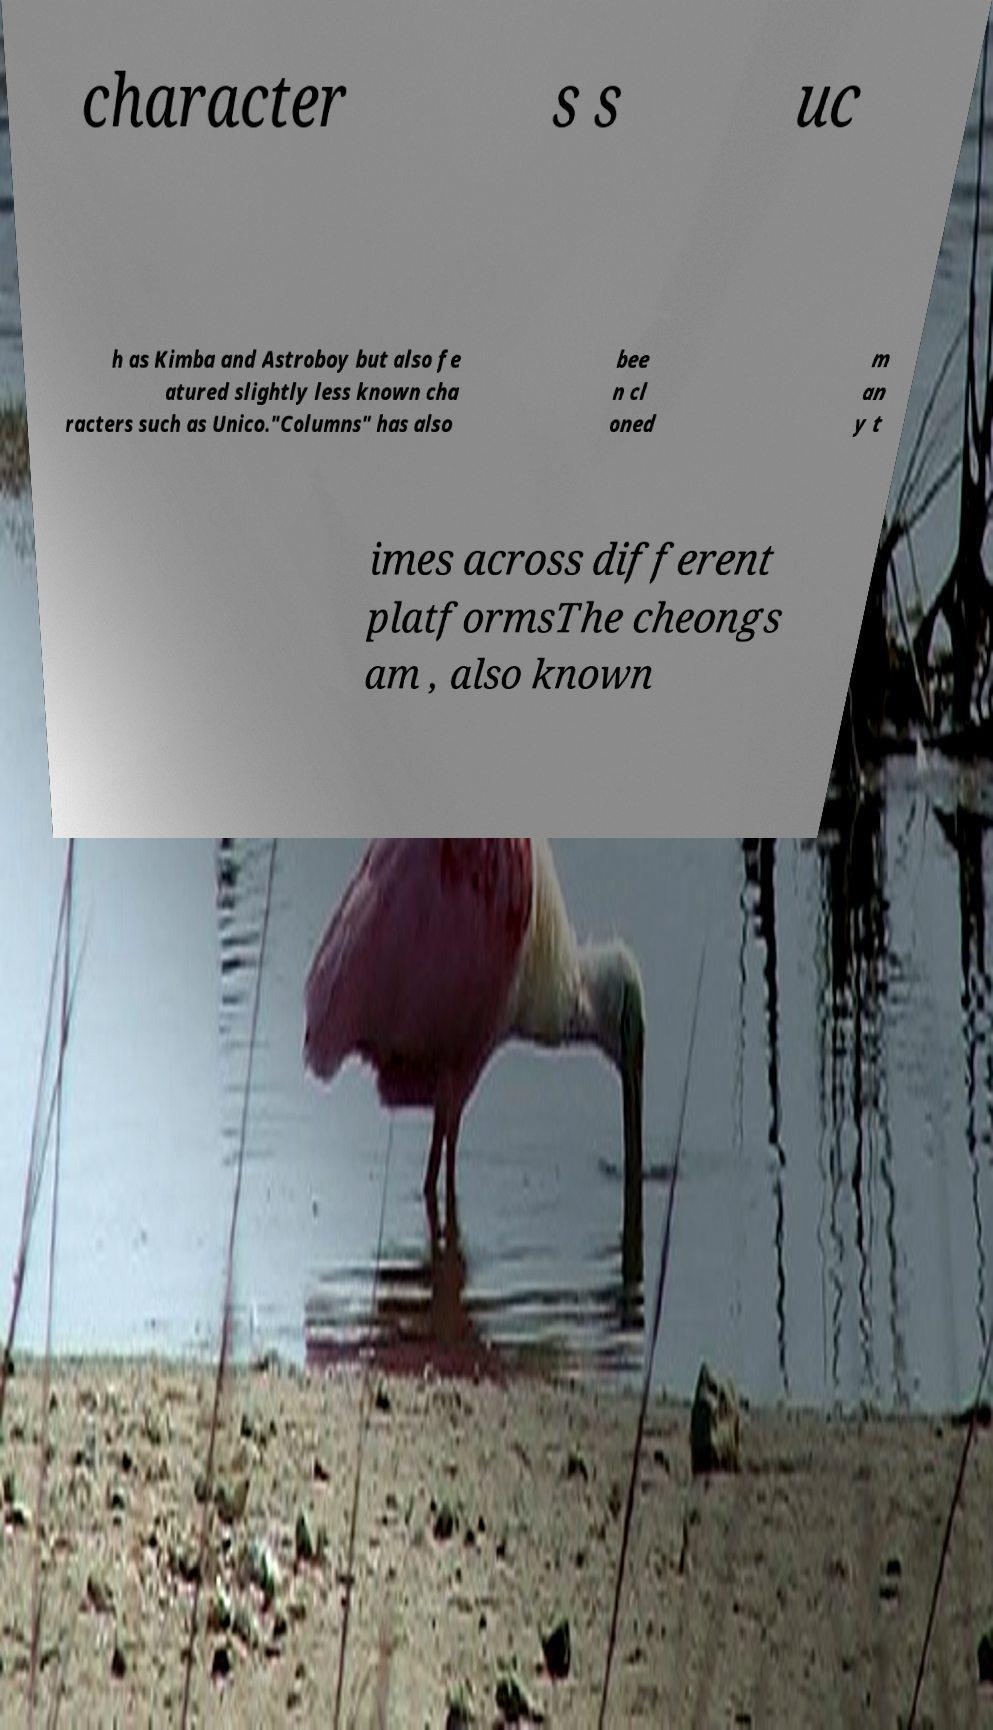Please read and relay the text visible in this image. What does it say? character s s uc h as Kimba and Astroboy but also fe atured slightly less known cha racters such as Unico."Columns" has also bee n cl oned m an y t imes across different platformsThe cheongs am , also known 